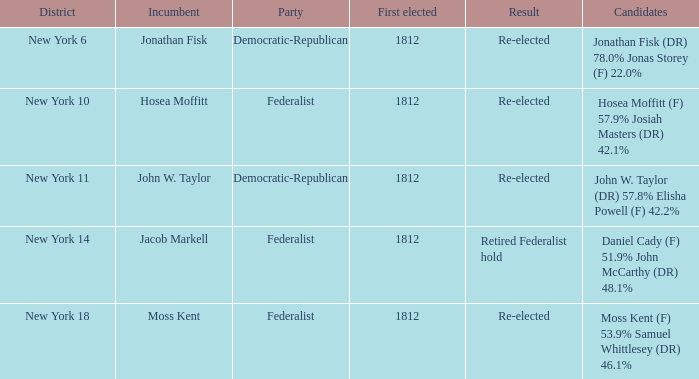Name the incumbent for new york 10 Hosea Moffitt. 